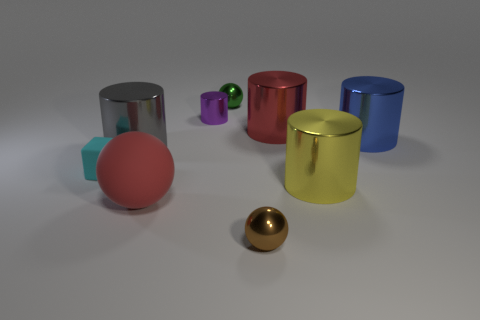Subtract all red cylinders. How many cylinders are left? 4 Subtract all red cylinders. How many cylinders are left? 4 Subtract all purple cylinders. Subtract all green blocks. How many cylinders are left? 4 Add 1 tiny cyan blocks. How many objects exist? 10 Subtract all cubes. How many objects are left? 8 Subtract all cylinders. Subtract all purple objects. How many objects are left? 3 Add 6 green shiny spheres. How many green shiny spheres are left? 7 Add 4 tiny red rubber spheres. How many tiny red rubber spheres exist? 4 Subtract 0 cyan spheres. How many objects are left? 9 